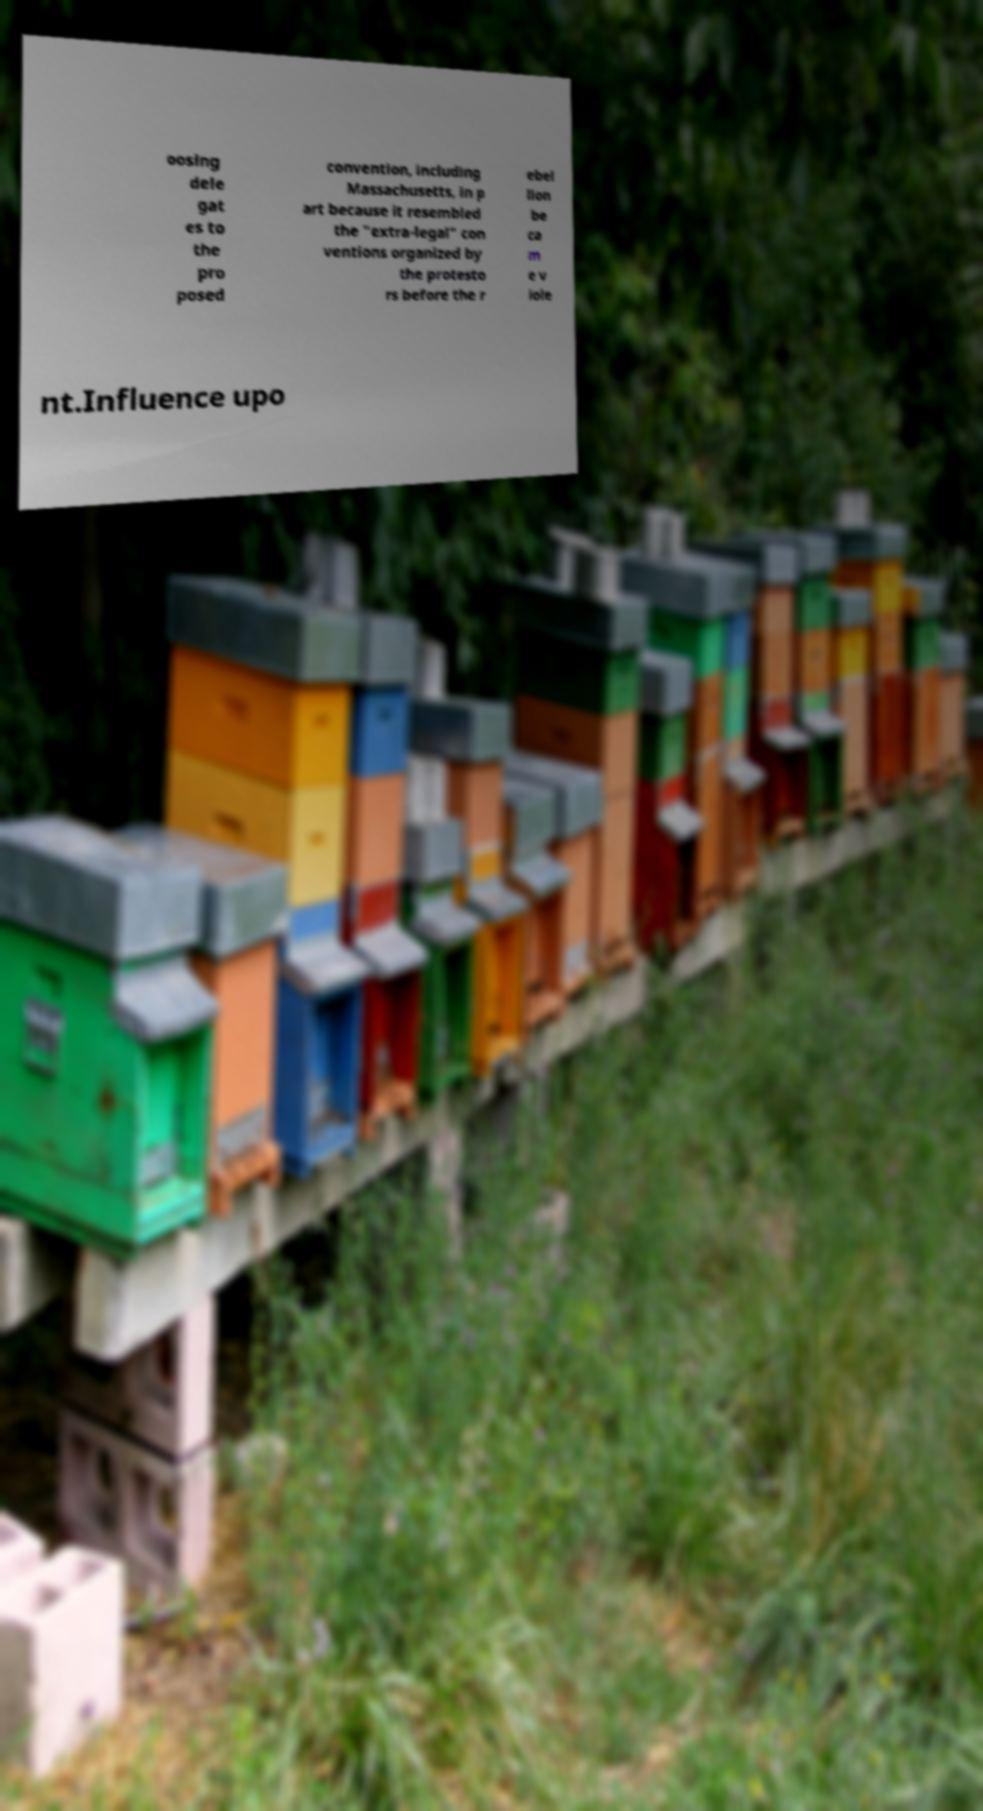Can you read and provide the text displayed in the image?This photo seems to have some interesting text. Can you extract and type it out for me? oosing dele gat es to the pro posed convention, including Massachusetts, in p art because it resembled the "extra-legal" con ventions organized by the protesto rs before the r ebel lion be ca m e v iole nt.Influence upo 